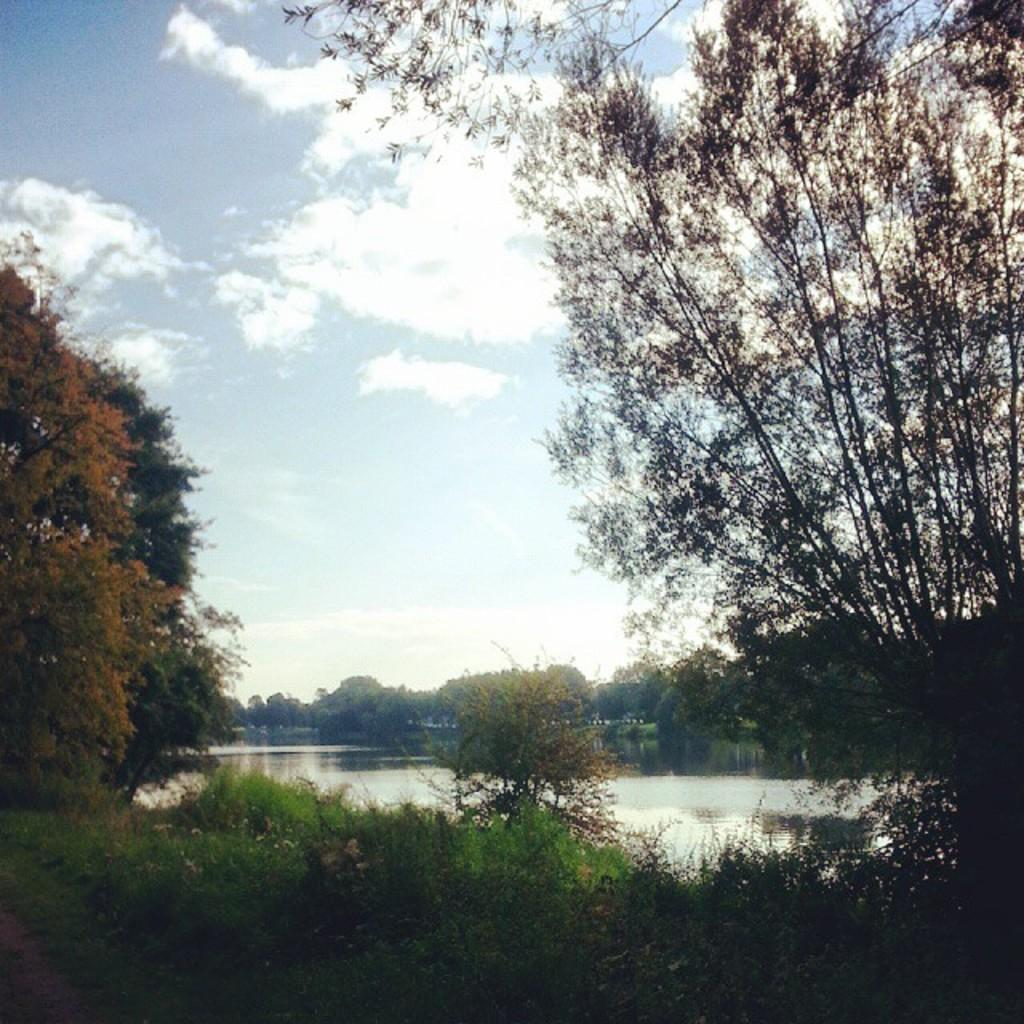What type of vegetation can be seen in the image? There are trees in the image. What color are the trees in the image? The trees are green. What else can be seen in the background of the image? There is water visible in the background of the image. How would you describe the sky in the image? The sky is blue and white. What type of vegetable is being used by the team in the image? There is no team or vegetable present in the image; it features trees, water, and a blue and white sky. 